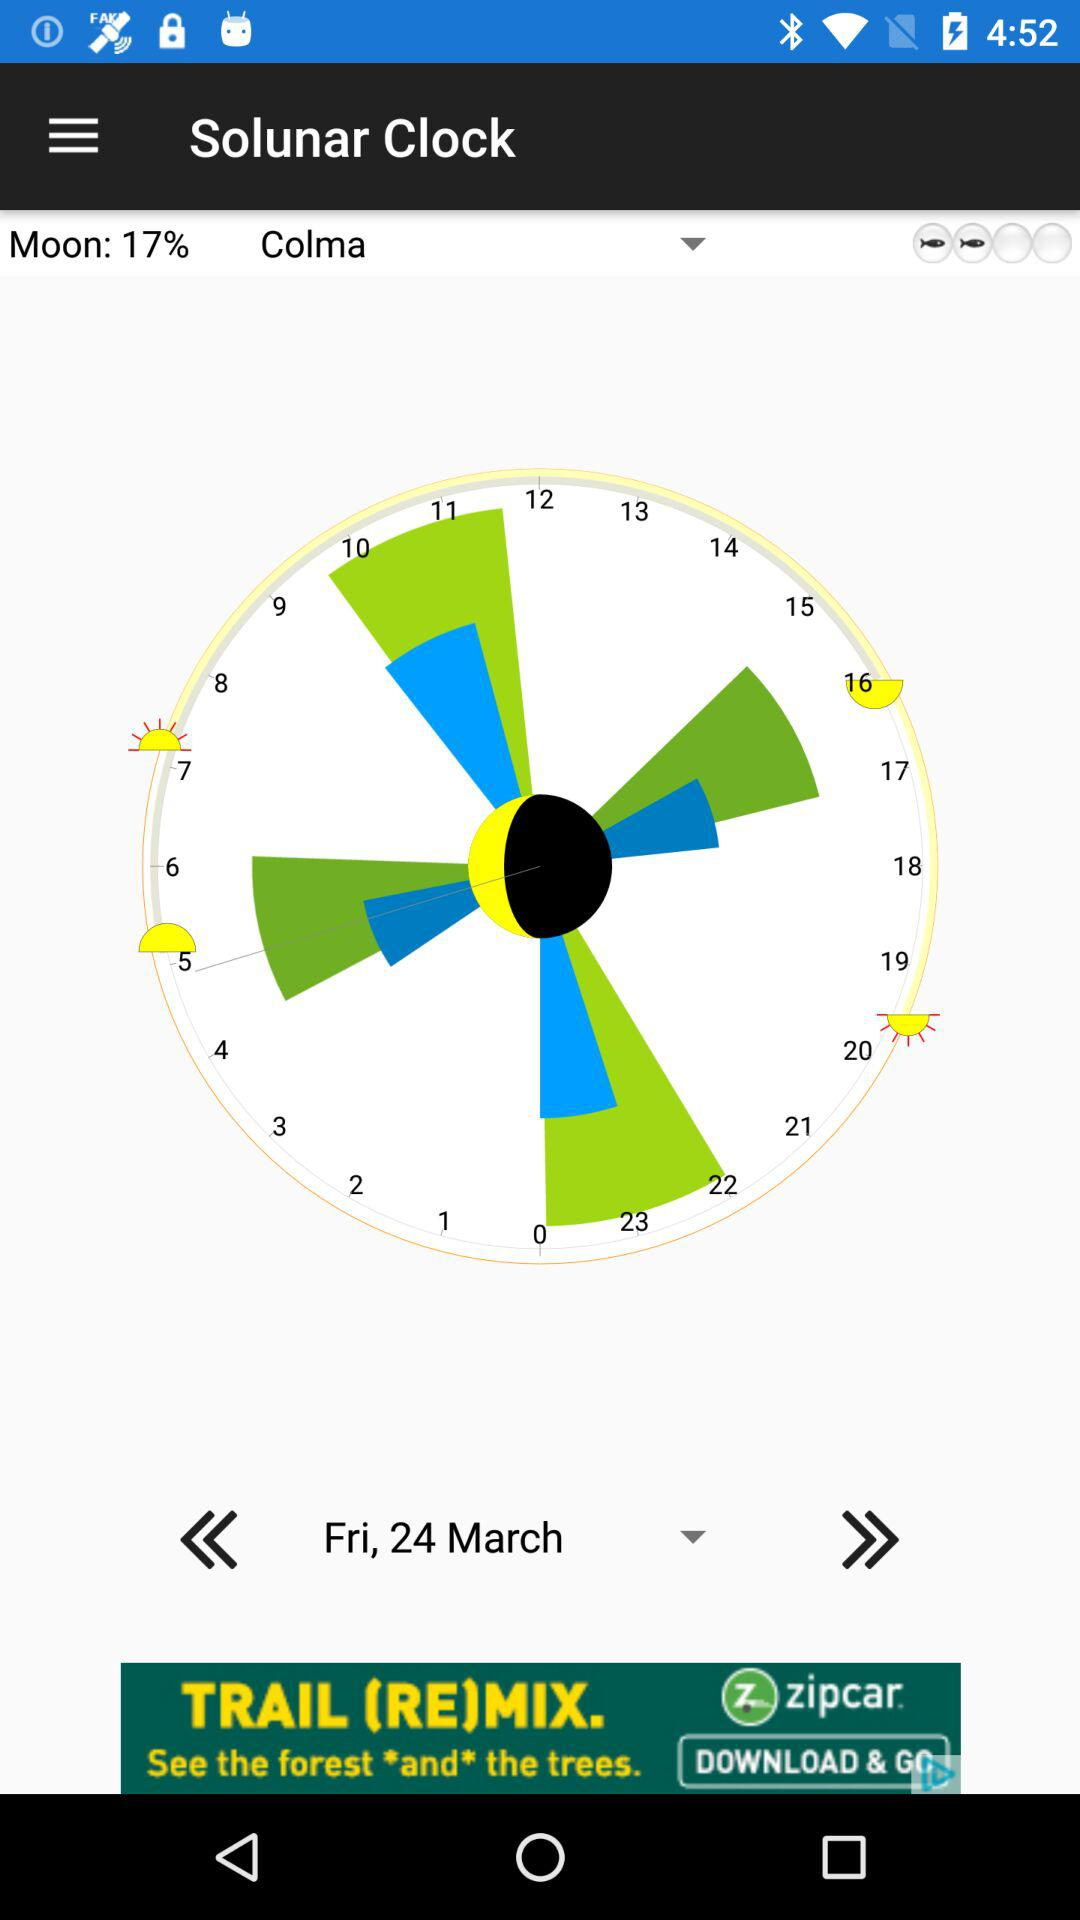What is the name of the application? The name of the application is "Solunar Clock". 